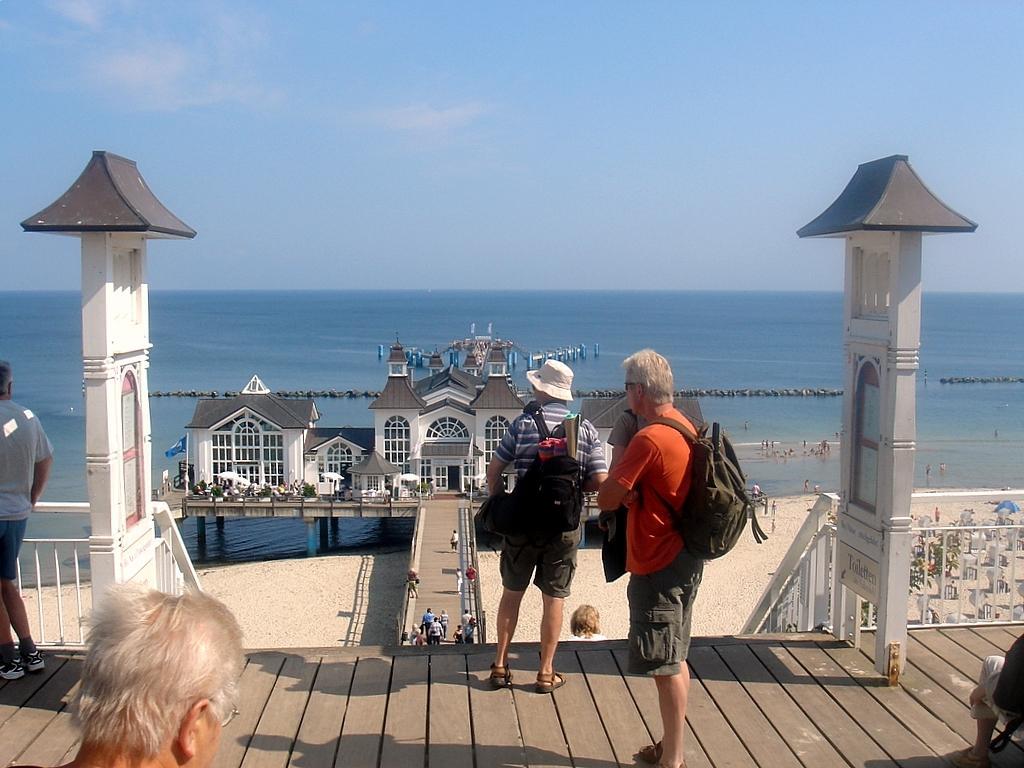How would you summarize this image in a sentence or two? In this image I see 3 men and 2 of them are wearing a bag and one of them is wearing a hat and they are standing on a path. In the background I can see sand over here and a bridge and a building which is of white in color and water over here and the sky is blue in color. 